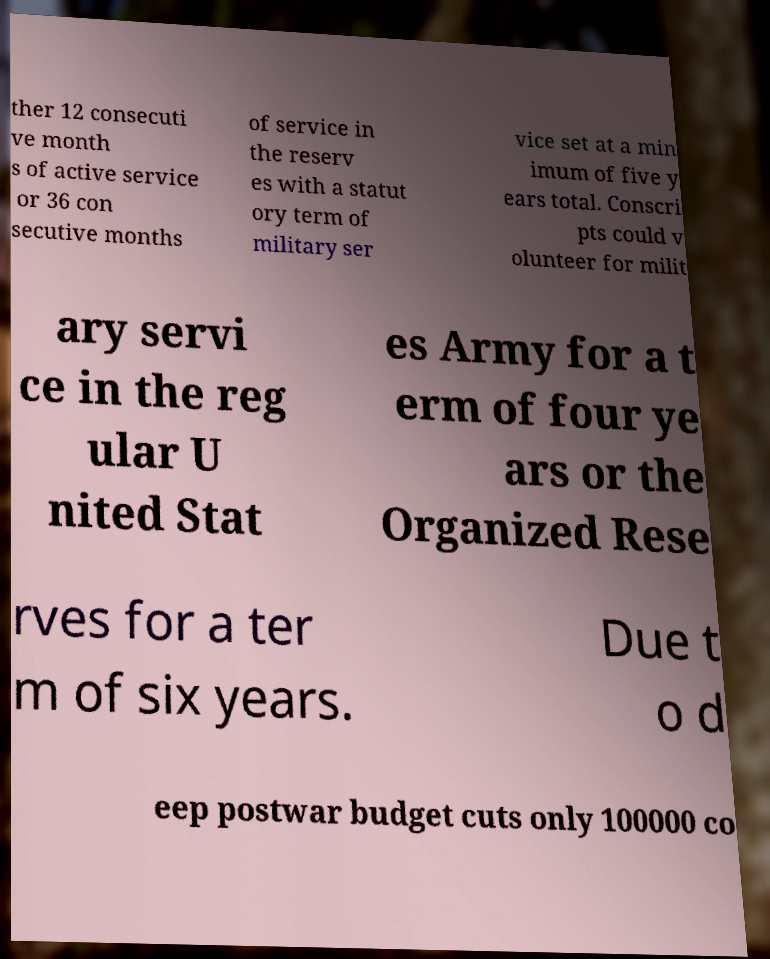Could you extract and type out the text from this image? ther 12 consecuti ve month s of active service or 36 con secutive months of service in the reserv es with a statut ory term of military ser vice set at a min imum of five y ears total. Conscri pts could v olunteer for milit ary servi ce in the reg ular U nited Stat es Army for a t erm of four ye ars or the Organized Rese rves for a ter m of six years. Due t o d eep postwar budget cuts only 100000 co 